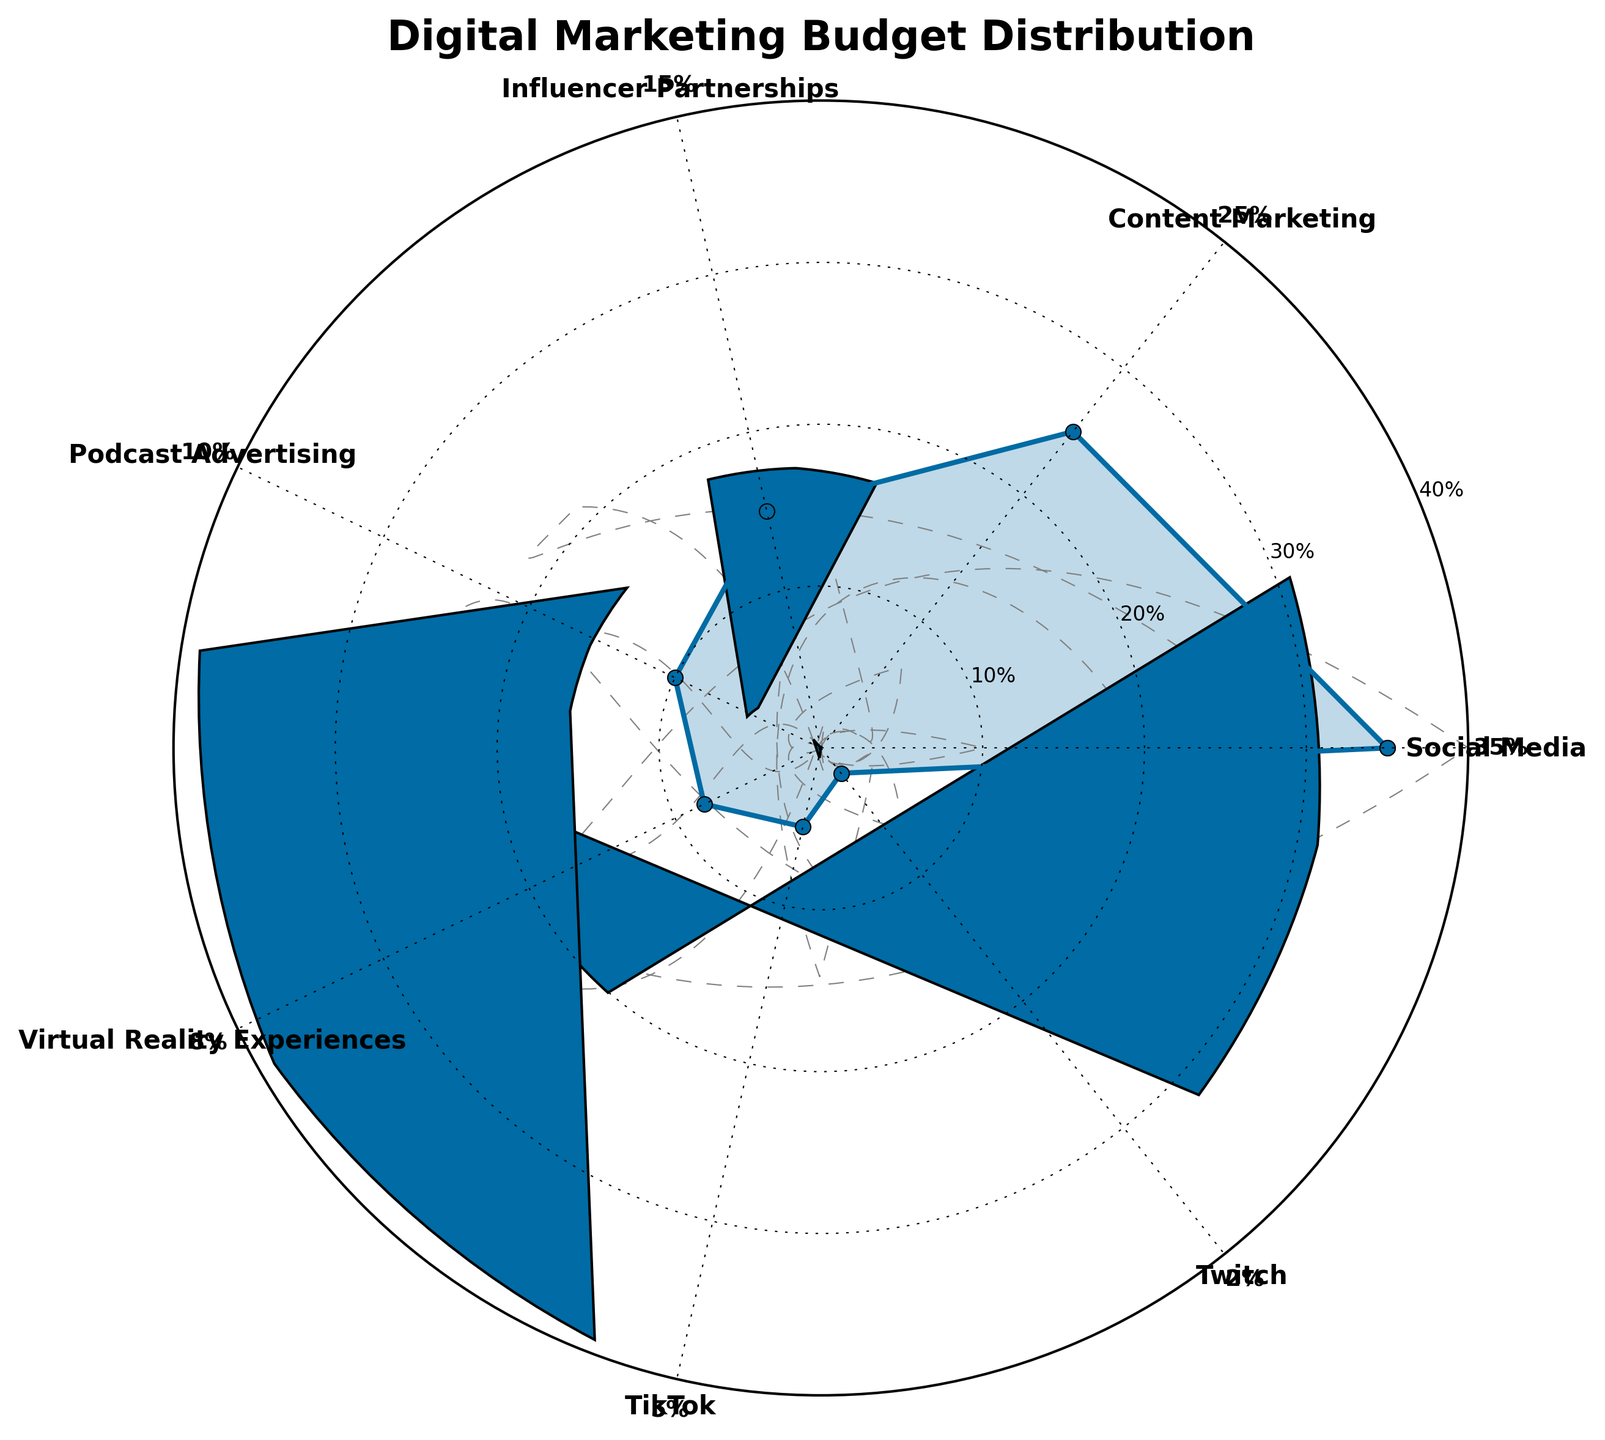what is the title of the figure? The title of the figure is placed at the top and reads "Digital Marketing Budget Distribution".
Answer: Digital Marketing Budget Distribution What is the highest percentage spent on? The highest percentage is indicated by the longest needle on the plot, which points to "Social Media" at 35%.
Answer: Social Media Which emerging platform has the lowest budget allocation? Among the emerging platforms identified as TikTok, Twitch, and Virtual Reality Experiences, the lowest budget allocation is for Twitch at 2%.
Answer: Twitch What is the combined percentage of budget spent on Podcast Advertising and Virtual Reality Experiences? The percentages for Podcast Advertising and Virtual Reality Experiences are 10% and 8% respectively, adding up to a combined 18%.
Answer: 18% How much more is spent on Social Media compared to TikTok? Social Media has a budget of 35%, while TikTok has 5%. The difference between them is 35% - 5% = 30%.
Answer: 30% What budget allocations are labeled with values exceeding 20%? The values exceeding 20% on the figure are Social Media (35%) and Content Marketing (25%).
Answer: Social Media, Content Marketing If the percentages for Influencer Partnerships and Twitch were combined, how would that compare to Content Marketing? Influencer Partnerships at 15% combined with Twitch at 2% makes 17%, which is less than Content Marketing at 25%.
Answer: Less than Content Marketing What is the average budget allocation across all channels? Sum of all percentages: 35 + 25 + 15 + 10 + 8 + 5 + 2 = 100. Average = 100% / 7 channels = ~14.29%.
Answer: ~14.29% Which channel has a 25% allocation, and what is the channel with the next highest allocation? The channel with a 25% allocation is Content Marketing. The next highest allocation is for Social Media at 35%.
Answer: Content Marketing, Social Media Which two channels have allocations totaling less than TikTok’s? The allocations for Twitch (2%) and Virtual Reality Experiences (8%) sum to 10%, which is more than TikTok's 5%. Instead, Influencer Partnerships (15%) and Twitch (2%) sum to 17% which exceeds TikTok's allocation as well. No two specific channels sum to less than TikTok's allocation of 5%.
Answer: None What visual element besides the labels indicates the budget percentage for each channel? The gauge needles extending from the center towards each labeled channel indicate the budget percentage visually.
Answer: Gauge needles 